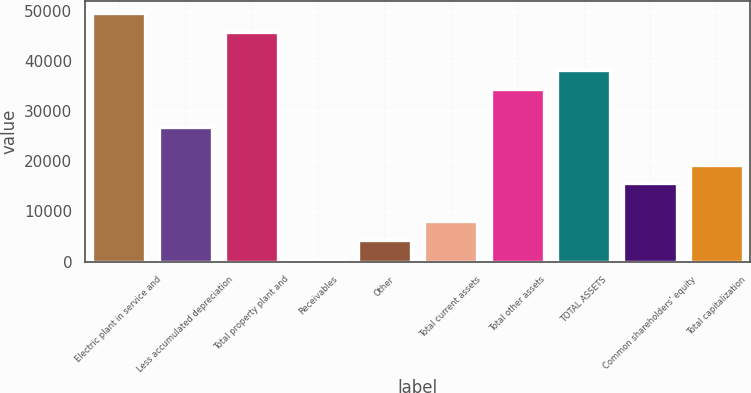Convert chart. <chart><loc_0><loc_0><loc_500><loc_500><bar_chart><fcel>Electric plant in service and<fcel>Less accumulated depreciation<fcel>Total property plant and<fcel>Receivables<fcel>Other<fcel>Total current assets<fcel>Total other assets<fcel>TOTAL ASSETS<fcel>Common shareholders' equity<fcel>Total capitalization<nl><fcel>49587.4<fcel>26908.6<fcel>45807.6<fcel>450<fcel>4229.8<fcel>8009.6<fcel>34468.2<fcel>38248<fcel>15569.2<fcel>19349<nl></chart> 